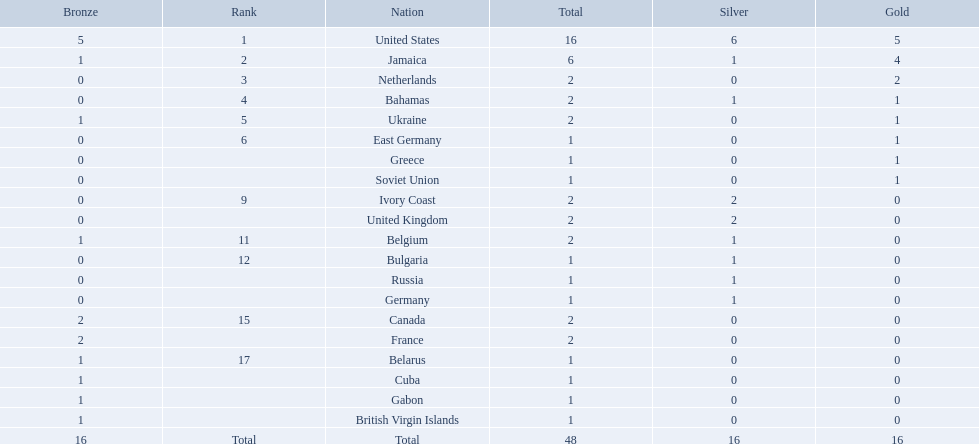Which nations took home at least one gold medal in the 60 metres competition? United States, Jamaica, Netherlands, Bahamas, Ukraine, East Germany, Greece, Soviet Union. Of these nations, which one won the most gold medals? United States. Could you parse the entire table as a dict? {'header': ['Bronze', 'Rank', 'Nation', 'Total', 'Silver', 'Gold'], 'rows': [['5', '1', 'United States', '16', '6', '5'], ['1', '2', 'Jamaica', '6', '1', '4'], ['0', '3', 'Netherlands', '2', '0', '2'], ['0', '4', 'Bahamas', '2', '1', '1'], ['1', '5', 'Ukraine', '2', '0', '1'], ['0', '6', 'East Germany', '1', '0', '1'], ['0', '', 'Greece', '1', '0', '1'], ['0', '', 'Soviet Union', '1', '0', '1'], ['0', '9', 'Ivory Coast', '2', '2', '0'], ['0', '', 'United Kingdom', '2', '2', '0'], ['1', '11', 'Belgium', '2', '1', '0'], ['0', '12', 'Bulgaria', '1', '1', '0'], ['0', '', 'Russia', '1', '1', '0'], ['0', '', 'Germany', '1', '1', '0'], ['2', '15', 'Canada', '2', '0', '0'], ['2', '', 'France', '2', '0', '0'], ['1', '17', 'Belarus', '1', '0', '0'], ['1', '', 'Cuba', '1', '0', '0'], ['1', '', 'Gabon', '1', '0', '0'], ['1', '', 'British Virgin Islands', '1', '0', '0'], ['16', 'Total', 'Total', '48', '16', '16']]} 